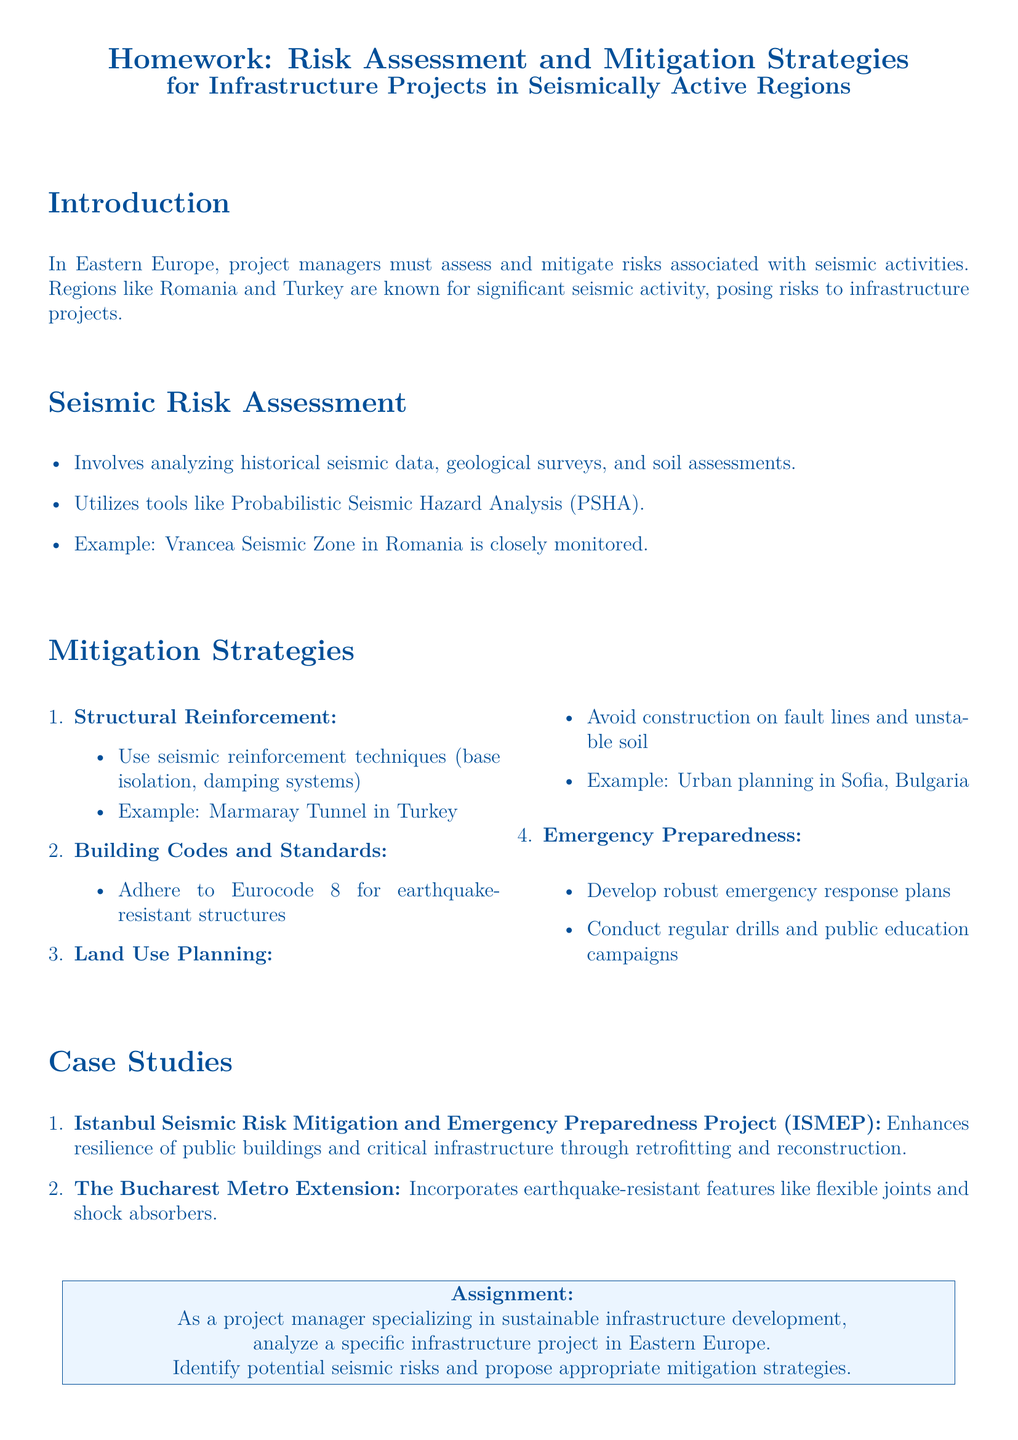What is the main focus of the homework? The homework focuses on risk assessment and mitigation strategies for infrastructure projects in seismically active regions.
Answer: Risk assessment and mitigation strategies Which region is known for significant seismic activity as mentioned in the introduction? The introduction mentions Romania and Turkey as regions known for seismic activity.
Answer: Romania and Turkey What analysis tool is mentioned for seismic risk assessment? The document mentions Probabilistic Seismic Hazard Analysis (PSHA) as a tool for seismic risk assessment.
Answer: Probabilistic Seismic Hazard Analysis What example of seismic reinforcement is provided in the document? The document provides the Marmaray Tunnel in Turkey as an example of seismic reinforcement techniques.
Answer: Marmaray Tunnel What building code should be adhered to for earthquake-resistant structures? The document specifies that Eurocode 8 should be adhered to for earthquake-resistant structures.
Answer: Eurocode 8 What is the objective of the Istanbul Seismic Risk Mitigation and Emergency Preparedness Project (ISMEP)? The objective is to enhance the resilience of public buildings and critical infrastructure through retrofitting and reconstruction.
Answer: Enhance resilience through retrofitting and reconstruction What should be avoided in land use planning according to the document? The document advises avoiding construction on fault lines and unstable soil in land use planning.
Answer: Fault lines and unstable soil What type of plan should be developed for emergency preparedness? The document states that robust emergency response plans should be developed for emergency preparedness.
Answer: Robust emergency response plans 